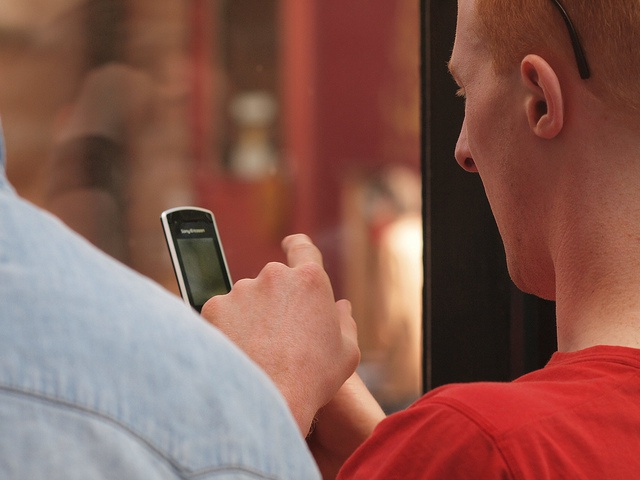Describe the objects in this image and their specific colors. I can see people in tan, maroon, and brown tones, people in tan, darkgray, and lightgray tones, and cell phone in tan, black, darkgreen, gray, and brown tones in this image. 